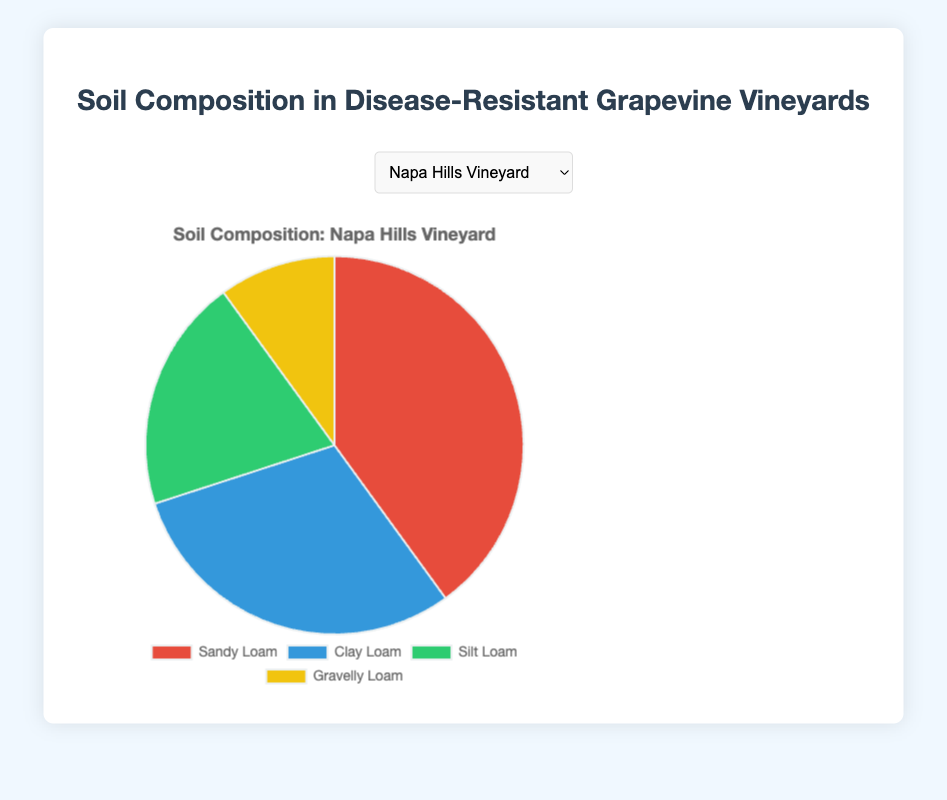Which vineyard has the highest proportion of Gravelly Loam soil? We need to compare the proportions of gravelly loam soil across different vineyards. “Bordeaux Reserve” has 50% Gravelly Loam soil, which is the highest compared to “Napa Hills Vineyard” with 10%. The other vineyards do not have this type of soil.
Answer: Bordeaux Reserve How much larger is the percentage of Sandy Loam in Napa Hills Vineyard compared to Sonoma Valley Estate? For Napa Hills Vineyard, Sandy Loam is at 40%. For Sonoma Valley Estate, it is 35%. The difference is 40% - 35% = 5%.
Answer: 5% Which vineyard has the widest variety of soil types? To determine this, count the number of different soil types listed for each vineyard. “Napa Hills Vineyard” has 4, “Sonoma Valley Estate” has 4, “Bordeaux Reserve” has 4, “Tuscany Heritage” has 4, and “Marlborough Vines” has 4. Thus, all vineyards have 4 soil types.
Answer: All vineyards In which vineyard is Clay Loam the most prevalent? We need to compare the percentages of Clay Loam soil among the vineyards. Napa Hills Vineyard has 30%, Sonoma Valley Estate 25%, Bordeaux Reserve 15%, Tuscany Heritage 35%, and Marlborough Vines 25%. Tuscany Heritage has the highest percentage of Clay Loam soil at 35%.
Answer: Tuscany Heritage What is the combined percentage of Silt Loam and Gravelly Loam soils in Napa Hills Vineyard? To find the combined percentage, add the proportions of Silt Loam and Gravelly Loam soils at Napa Hills Vineyard. This is 20% (Silt Loam) + 10% (Gravelly Loam) = 30%.
Answer: 30% Which vineyard's chart segment representing Chalky Soil is the smallest among all vineyards? Looking at the soil types and their proportions, Chalky Soil appears only in Sonoma Valley Estate and it represents 10% of the total soil composition. We need to confirm that it is unique and that no other vineyard has a smaller Chalky Soil proportion.
Answer: Sonoma Valley Estate In the composition of Bordeaux Reserve, what is the ratio of Gravelly Loam to Sandy Loam? Gravelly Loam in Bordeaux Reserve is 50% and Sandy Loam is 20%. The ratio of Gravelly Loam to Sandy Loam is 50:20, which reduces to 5:2.
Answer: 5:2 Which vineyard has the highest percentage of a single soil type? The analysis requires comparing the highest percentages from each vineyard’s soil composition. Bordeaux Reserve has 50% Gravelly Loam, which is the highest among all vineyards for any single soil type.
Answer: Bordeaux Reserve How does the percentage of Clay Loam in Marlborough Vines compare to the percentage of Sandy Loam in the same vineyard? For Marlborough Vines, Clay Loam is at 25% and Sandy Loam is at 35%. Hence, Sandy Loam is 10% higher than Clay Loam in Marlborough Vines.
Answer: Sandy Loam is 10% higher What is the average percentage of Sandy Loam across all vineyards? Calculate by summing up the percentages of Sandy Loam in each vineyard and dividing by the number of vineyards. The percentages are 40% (Napa Hills Vineyard), 35% (Sonoma Valley Estate), 20% (Bordeaux Reserve), 40% (Tuscany Heritage), and 35% (Marlborough Vines). Thus, the total is 40% + 35% + 20% + 40% + 35% = 170%, and the average is 170%/5 = 34%.
Answer: 34% 